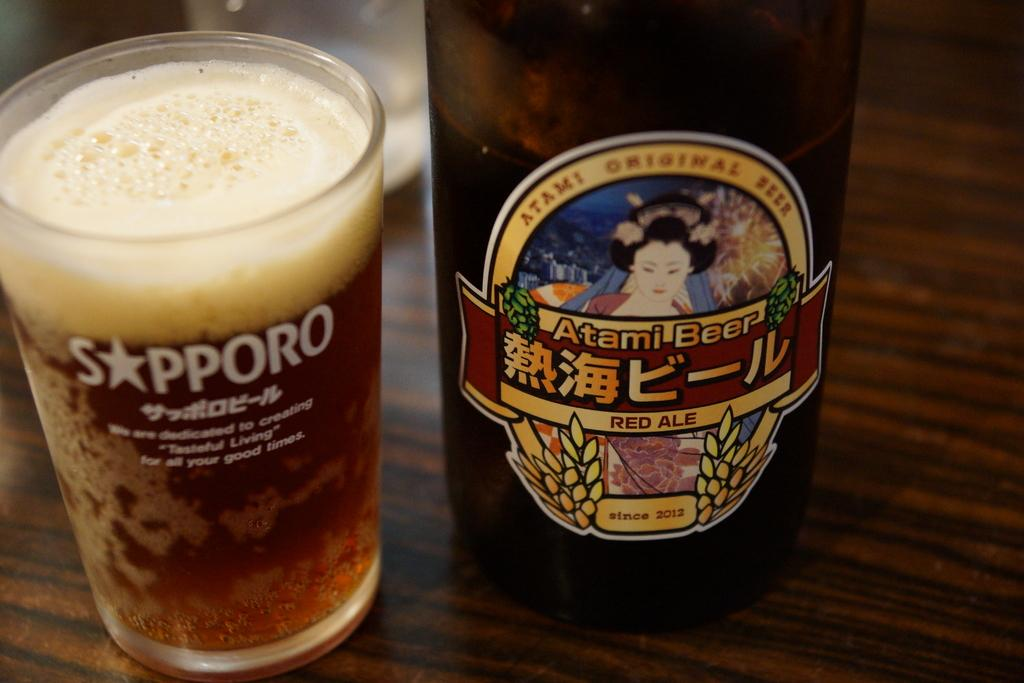<image>
Render a clear and concise summary of the photo. A bottle of Atami beer has been poured into a glass 